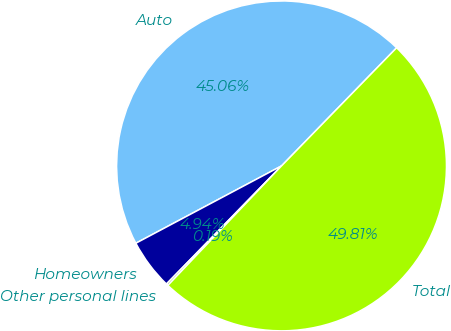Convert chart to OTSL. <chart><loc_0><loc_0><loc_500><loc_500><pie_chart><fcel>Auto<fcel>Homeowners<fcel>Other personal lines<fcel>Total<nl><fcel>45.06%<fcel>4.94%<fcel>0.19%<fcel>49.81%<nl></chart> 